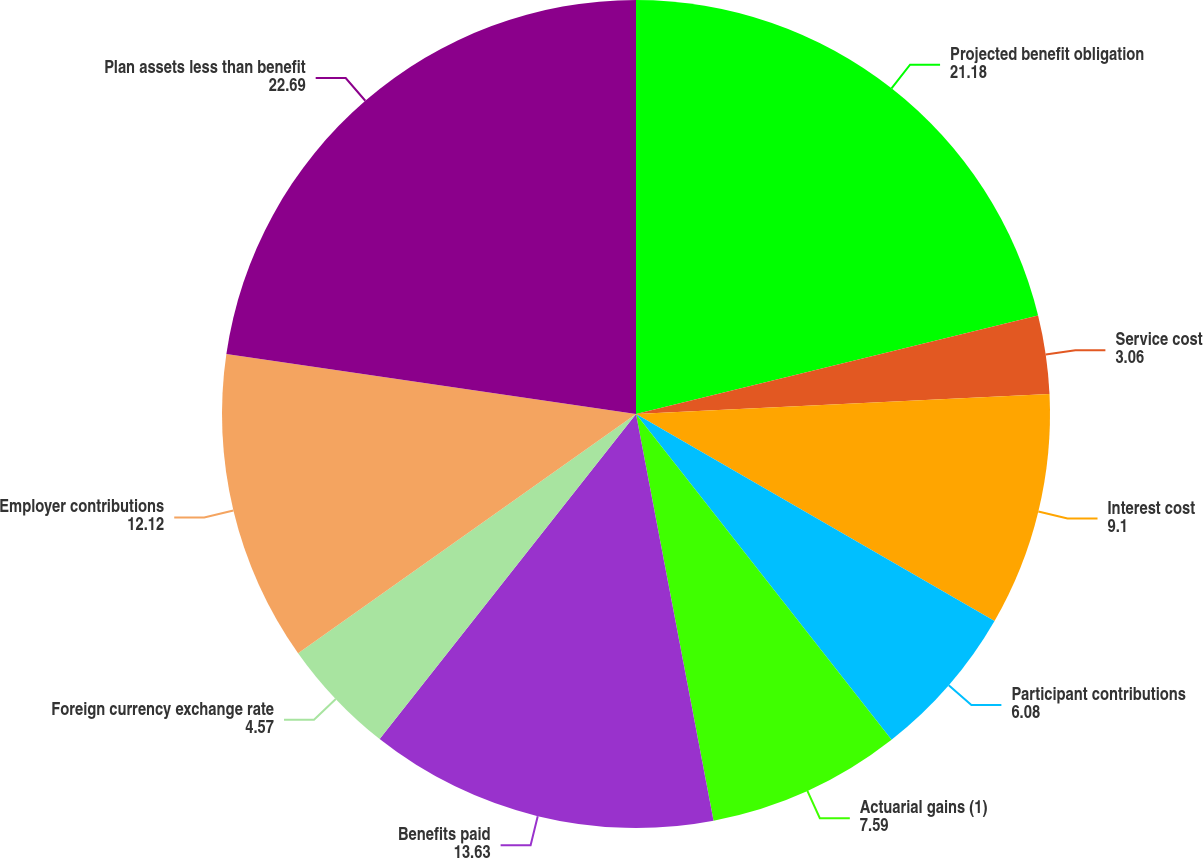Convert chart to OTSL. <chart><loc_0><loc_0><loc_500><loc_500><pie_chart><fcel>Projected benefit obligation<fcel>Service cost<fcel>Interest cost<fcel>Participant contributions<fcel>Actuarial gains (1)<fcel>Benefits paid<fcel>Foreign currency exchange rate<fcel>Employer contributions<fcel>Plan assets less than benefit<nl><fcel>21.18%<fcel>3.06%<fcel>9.1%<fcel>6.08%<fcel>7.59%<fcel>13.63%<fcel>4.57%<fcel>12.12%<fcel>22.69%<nl></chart> 